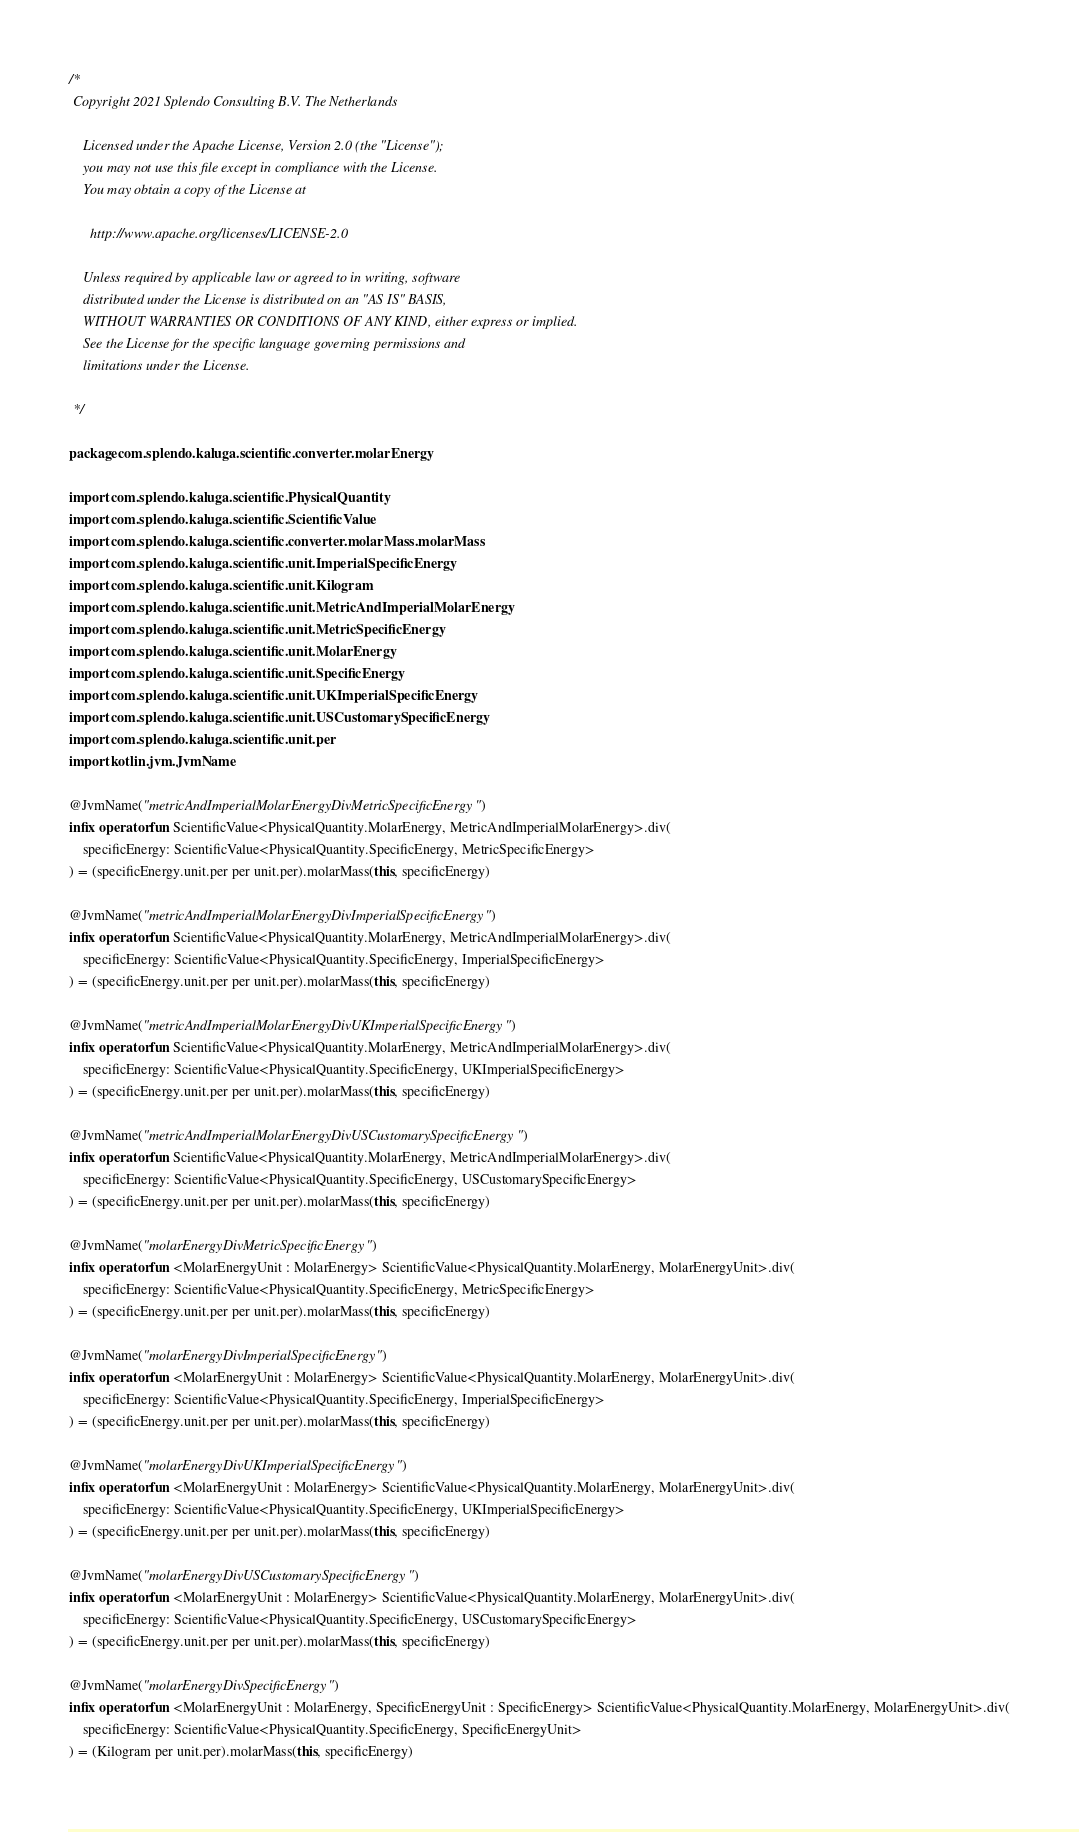Convert code to text. <code><loc_0><loc_0><loc_500><loc_500><_Kotlin_>/*
 Copyright 2021 Splendo Consulting B.V. The Netherlands

    Licensed under the Apache License, Version 2.0 (the "License");
    you may not use this file except in compliance with the License.
    You may obtain a copy of the License at

      http://www.apache.org/licenses/LICENSE-2.0

    Unless required by applicable law or agreed to in writing, software
    distributed under the License is distributed on an "AS IS" BASIS,
    WITHOUT WARRANTIES OR CONDITIONS OF ANY KIND, either express or implied.
    See the License for the specific language governing permissions and
    limitations under the License.

 */

package com.splendo.kaluga.scientific.converter.molarEnergy

import com.splendo.kaluga.scientific.PhysicalQuantity
import com.splendo.kaluga.scientific.ScientificValue
import com.splendo.kaluga.scientific.converter.molarMass.molarMass
import com.splendo.kaluga.scientific.unit.ImperialSpecificEnergy
import com.splendo.kaluga.scientific.unit.Kilogram
import com.splendo.kaluga.scientific.unit.MetricAndImperialMolarEnergy
import com.splendo.kaluga.scientific.unit.MetricSpecificEnergy
import com.splendo.kaluga.scientific.unit.MolarEnergy
import com.splendo.kaluga.scientific.unit.SpecificEnergy
import com.splendo.kaluga.scientific.unit.UKImperialSpecificEnergy
import com.splendo.kaluga.scientific.unit.USCustomarySpecificEnergy
import com.splendo.kaluga.scientific.unit.per
import kotlin.jvm.JvmName

@JvmName("metricAndImperialMolarEnergyDivMetricSpecificEnergy")
infix operator fun ScientificValue<PhysicalQuantity.MolarEnergy, MetricAndImperialMolarEnergy>.div(
    specificEnergy: ScientificValue<PhysicalQuantity.SpecificEnergy, MetricSpecificEnergy>
) = (specificEnergy.unit.per per unit.per).molarMass(this, specificEnergy)

@JvmName("metricAndImperialMolarEnergyDivImperialSpecificEnergy")
infix operator fun ScientificValue<PhysicalQuantity.MolarEnergy, MetricAndImperialMolarEnergy>.div(
    specificEnergy: ScientificValue<PhysicalQuantity.SpecificEnergy, ImperialSpecificEnergy>
) = (specificEnergy.unit.per per unit.per).molarMass(this, specificEnergy)

@JvmName("metricAndImperialMolarEnergyDivUKImperialSpecificEnergy")
infix operator fun ScientificValue<PhysicalQuantity.MolarEnergy, MetricAndImperialMolarEnergy>.div(
    specificEnergy: ScientificValue<PhysicalQuantity.SpecificEnergy, UKImperialSpecificEnergy>
) = (specificEnergy.unit.per per unit.per).molarMass(this, specificEnergy)

@JvmName("metricAndImperialMolarEnergyDivUSCustomarySpecificEnergy")
infix operator fun ScientificValue<PhysicalQuantity.MolarEnergy, MetricAndImperialMolarEnergy>.div(
    specificEnergy: ScientificValue<PhysicalQuantity.SpecificEnergy, USCustomarySpecificEnergy>
) = (specificEnergy.unit.per per unit.per).molarMass(this, specificEnergy)

@JvmName("molarEnergyDivMetricSpecificEnergy")
infix operator fun <MolarEnergyUnit : MolarEnergy> ScientificValue<PhysicalQuantity.MolarEnergy, MolarEnergyUnit>.div(
    specificEnergy: ScientificValue<PhysicalQuantity.SpecificEnergy, MetricSpecificEnergy>
) = (specificEnergy.unit.per per unit.per).molarMass(this, specificEnergy)

@JvmName("molarEnergyDivImperialSpecificEnergy")
infix operator fun <MolarEnergyUnit : MolarEnergy> ScientificValue<PhysicalQuantity.MolarEnergy, MolarEnergyUnit>.div(
    specificEnergy: ScientificValue<PhysicalQuantity.SpecificEnergy, ImperialSpecificEnergy>
) = (specificEnergy.unit.per per unit.per).molarMass(this, specificEnergy)

@JvmName("molarEnergyDivUKImperialSpecificEnergy")
infix operator fun <MolarEnergyUnit : MolarEnergy> ScientificValue<PhysicalQuantity.MolarEnergy, MolarEnergyUnit>.div(
    specificEnergy: ScientificValue<PhysicalQuantity.SpecificEnergy, UKImperialSpecificEnergy>
) = (specificEnergy.unit.per per unit.per).molarMass(this, specificEnergy)

@JvmName("molarEnergyDivUSCustomarySpecificEnergy")
infix operator fun <MolarEnergyUnit : MolarEnergy> ScientificValue<PhysicalQuantity.MolarEnergy, MolarEnergyUnit>.div(
    specificEnergy: ScientificValue<PhysicalQuantity.SpecificEnergy, USCustomarySpecificEnergy>
) = (specificEnergy.unit.per per unit.per).molarMass(this, specificEnergy)

@JvmName("molarEnergyDivSpecificEnergy")
infix operator fun <MolarEnergyUnit : MolarEnergy, SpecificEnergyUnit : SpecificEnergy> ScientificValue<PhysicalQuantity.MolarEnergy, MolarEnergyUnit>.div(
    specificEnergy: ScientificValue<PhysicalQuantity.SpecificEnergy, SpecificEnergyUnit>
) = (Kilogram per unit.per).molarMass(this, specificEnergy)
</code> 